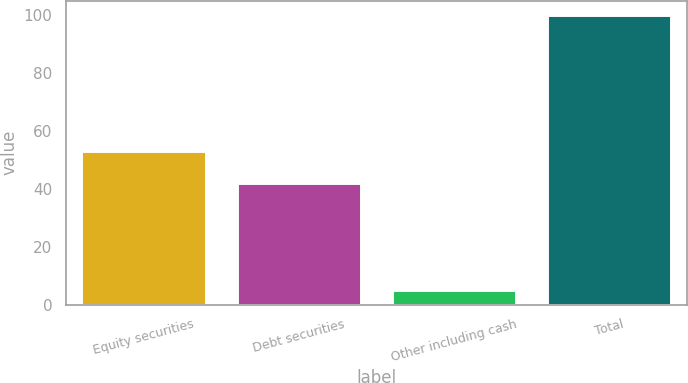Convert chart to OTSL. <chart><loc_0><loc_0><loc_500><loc_500><bar_chart><fcel>Equity securities<fcel>Debt securities<fcel>Other including cash<fcel>Total<nl><fcel>53<fcel>42<fcel>5<fcel>100<nl></chart> 